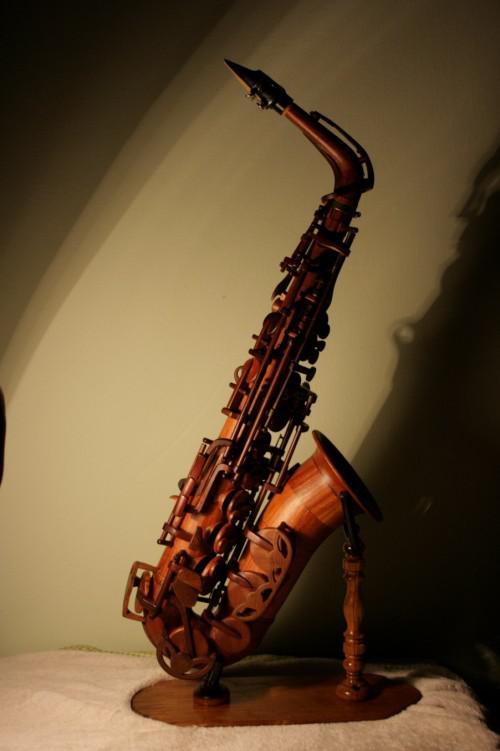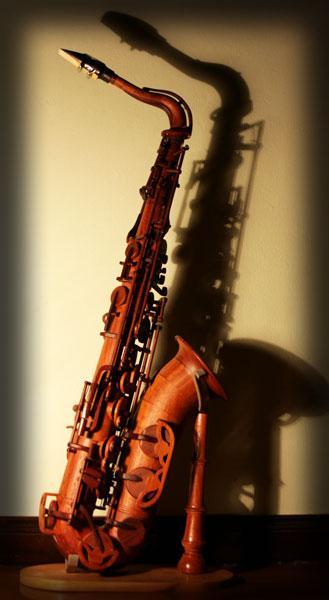The first image is the image on the left, the second image is the image on the right. Examine the images to the left and right. Is the description "One of the instruments has a plain white background." accurate? Answer yes or no. No. 